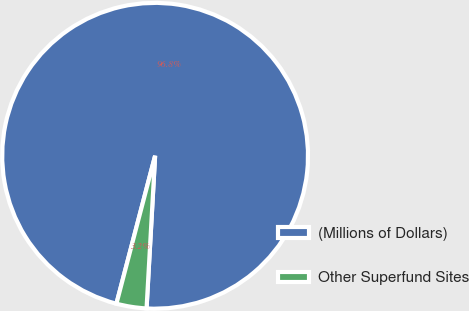Convert chart to OTSL. <chart><loc_0><loc_0><loc_500><loc_500><pie_chart><fcel>(Millions of Dollars)<fcel>Other Superfund Sites<nl><fcel>96.82%<fcel>3.18%<nl></chart> 